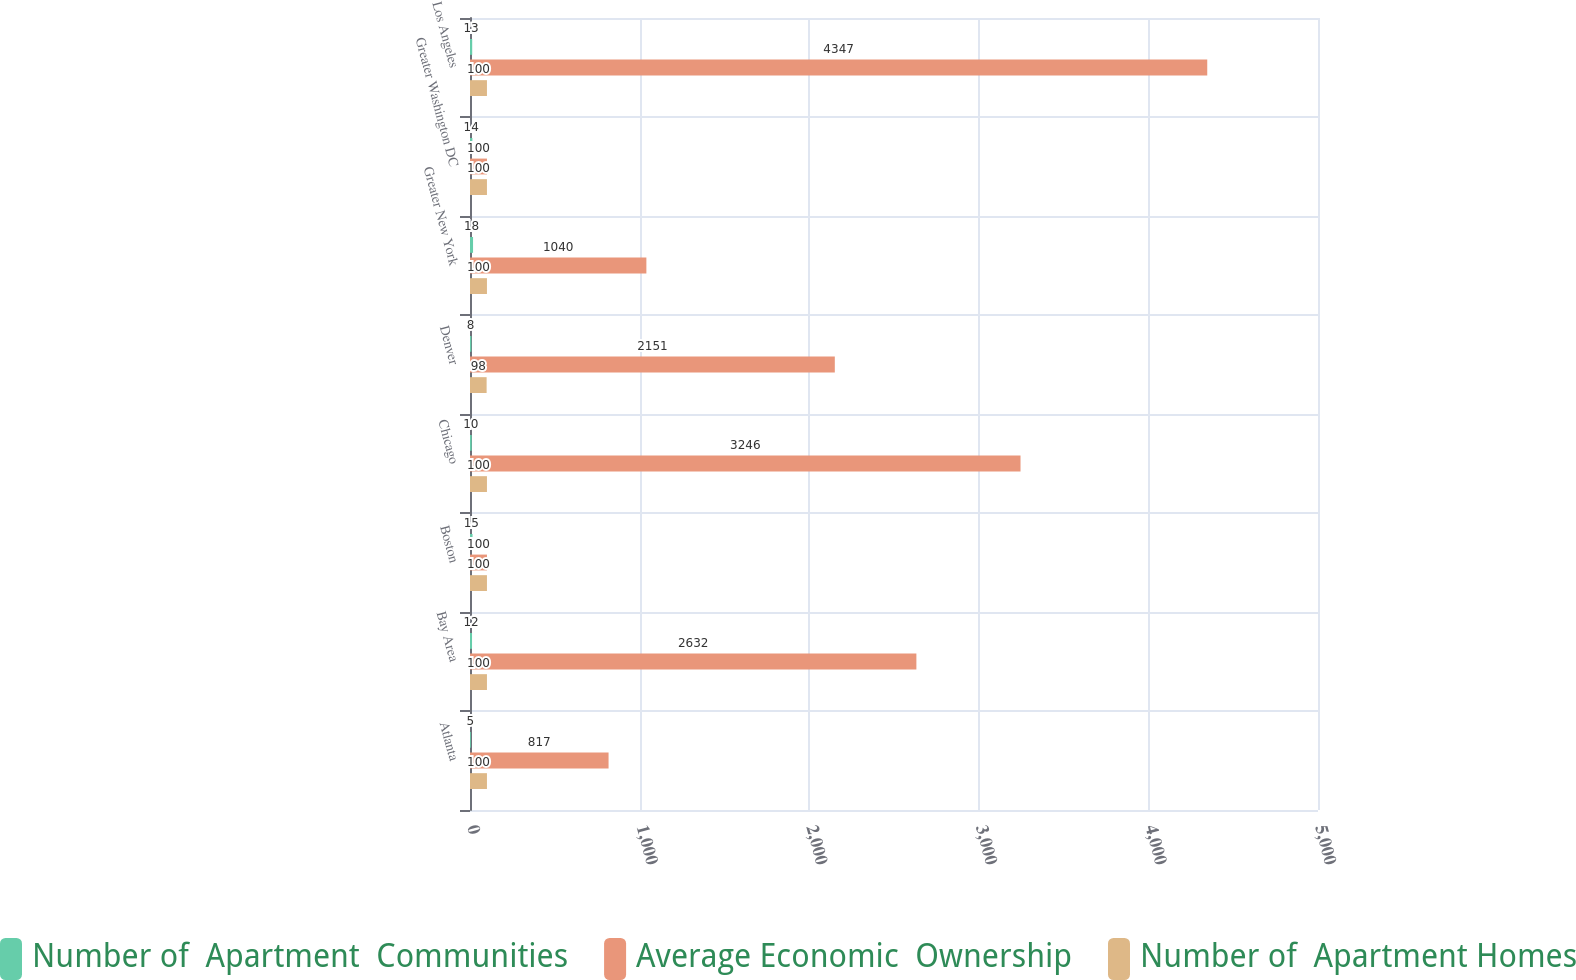Convert chart. <chart><loc_0><loc_0><loc_500><loc_500><stacked_bar_chart><ecel><fcel>Atlanta<fcel>Bay Area<fcel>Boston<fcel>Chicago<fcel>Denver<fcel>Greater New York<fcel>Greater Washington DC<fcel>Los Angeles<nl><fcel>Number of  Apartment  Communities<fcel>5<fcel>12<fcel>15<fcel>10<fcel>8<fcel>18<fcel>14<fcel>13<nl><fcel>Average Economic  Ownership<fcel>817<fcel>2632<fcel>100<fcel>3246<fcel>2151<fcel>1040<fcel>100<fcel>4347<nl><fcel>Number of  Apartment Homes<fcel>100<fcel>100<fcel>100<fcel>100<fcel>98<fcel>100<fcel>100<fcel>100<nl></chart> 